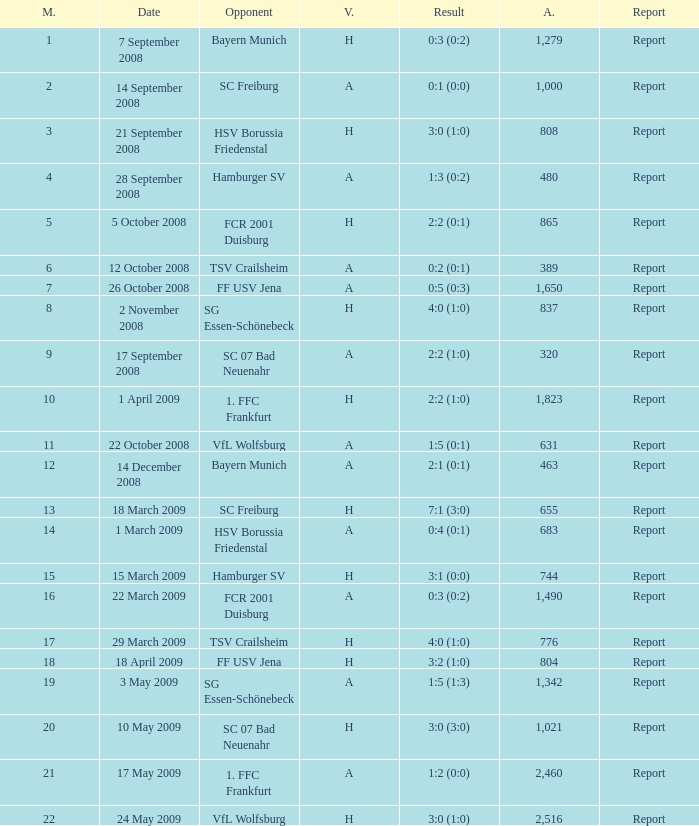Which match did FCR 2001 Duisburg participate as the opponent? 21.0. 